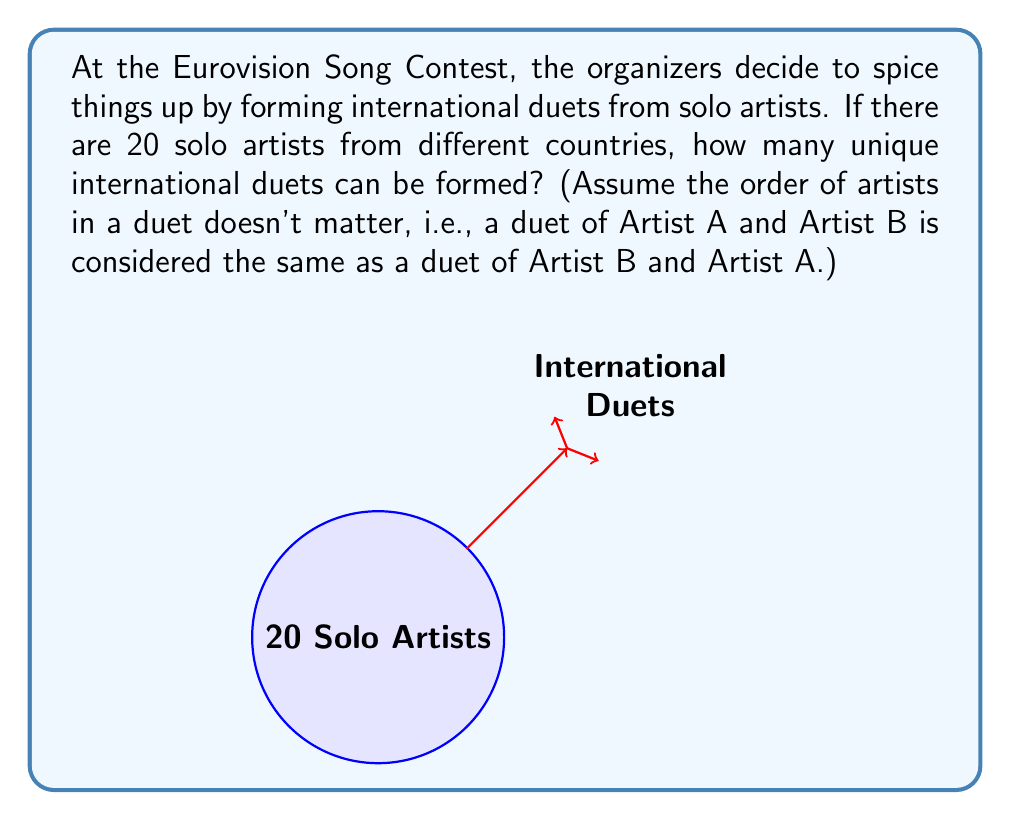Teach me how to tackle this problem. Let's break this down step-by-step:

1) We're essentially choosing 2 artists out of 20 to form a duet.

2) This is a combination problem, not a permutation, because the order doesn't matter (Artist A with Artist B is the same as Artist B with Artist A).

3) The formula for combinations is:

   $$C(n,r) = \frac{n!}{r!(n-r)!}$$

   Where $n$ is the total number of items to choose from, and $r$ is the number of items being chosen.

4) In this case, $n = 20$ (total number of solo artists) and $r = 2$ (we're choosing 2 for each duet).

5) Plugging these numbers into our formula:

   $$C(20,2) = \frac{20!}{2!(20-2)!} = \frac{20!}{2!(18)!}$$

6) Expanding this:

   $$\frac{20 * 19 * 18!}{2 * 1 * 18!}$$

7) The 18! cancels out in the numerator and denominator:

   $$\frac{20 * 19}{2 * 1} = \frac{380}{2} = 190$$

Therefore, 190 unique international duets can be formed.
Answer: 190 